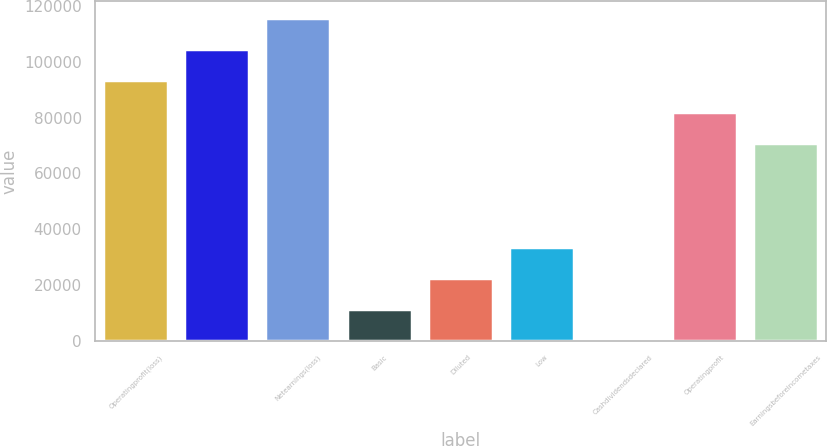Convert chart to OTSL. <chart><loc_0><loc_0><loc_500><loc_500><bar_chart><fcel>Operatingprofit(loss)<fcel>Unnamed: 1<fcel>Netearnings(loss)<fcel>Basic<fcel>Diluted<fcel>Low<fcel>Cashdividendsdeclared<fcel>Operatingprofit<fcel>Earningsbeforeincometaxes<nl><fcel>93335.3<fcel>104584<fcel>115834<fcel>11249.8<fcel>22498.9<fcel>33748.1<fcel>0.63<fcel>82086.1<fcel>70837<nl></chart> 